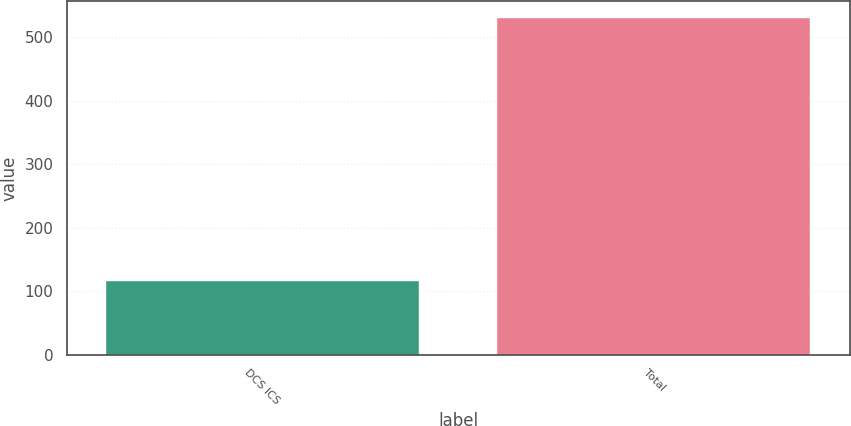Convert chart. <chart><loc_0><loc_0><loc_500><loc_500><bar_chart><fcel>DCS ICS<fcel>Total<nl><fcel>116<fcel>530<nl></chart> 